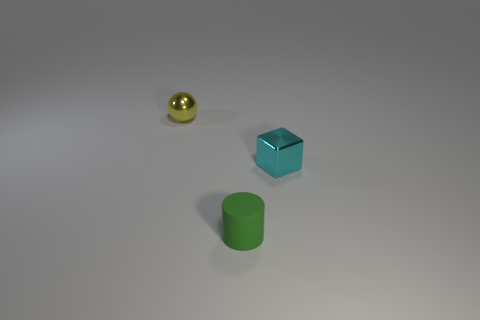Are there any other things that have the same material as the cyan block?
Give a very brief answer. Yes. What is the color of the small metallic thing that is right of the small metal sphere?
Your answer should be very brief. Cyan. Are there an equal number of tiny things in front of the metallic cube and large gray cylinders?
Offer a terse response. No. How many other objects are there of the same shape as the green object?
Keep it short and to the point. 0. There is a cyan block; what number of cylinders are behind it?
Ensure brevity in your answer.  0. How big is the object that is both on the left side of the small cyan object and behind the small cylinder?
Offer a terse response. Small. Are any tiny cylinders visible?
Keep it short and to the point. Yes. What number of other things are the same size as the matte cylinder?
Give a very brief answer. 2. There is a shiny object left of the cyan cube; is its color the same as the tiny object that is on the right side of the small matte object?
Offer a terse response. No. Do the object that is on the left side of the tiny rubber object and the small thing that is in front of the small cube have the same material?
Give a very brief answer. No. 